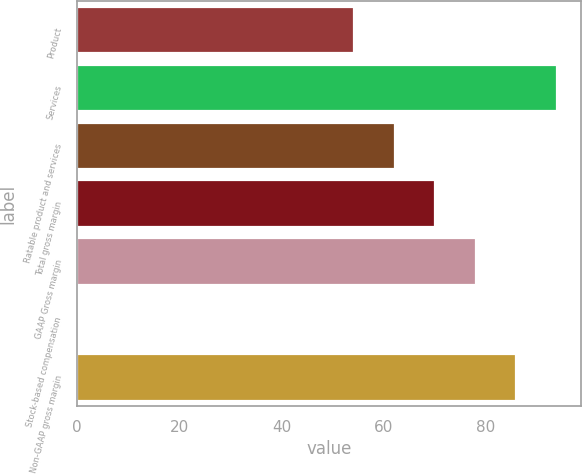<chart> <loc_0><loc_0><loc_500><loc_500><bar_chart><fcel>Product<fcel>Services<fcel>Ratable product and services<fcel>Total gross margin<fcel>GAAP Gross margin<fcel>Stock-based compensation<fcel>Non-GAAP gross margin<nl><fcel>54.2<fcel>93.8<fcel>62.12<fcel>70.04<fcel>77.96<fcel>0.2<fcel>85.88<nl></chart> 